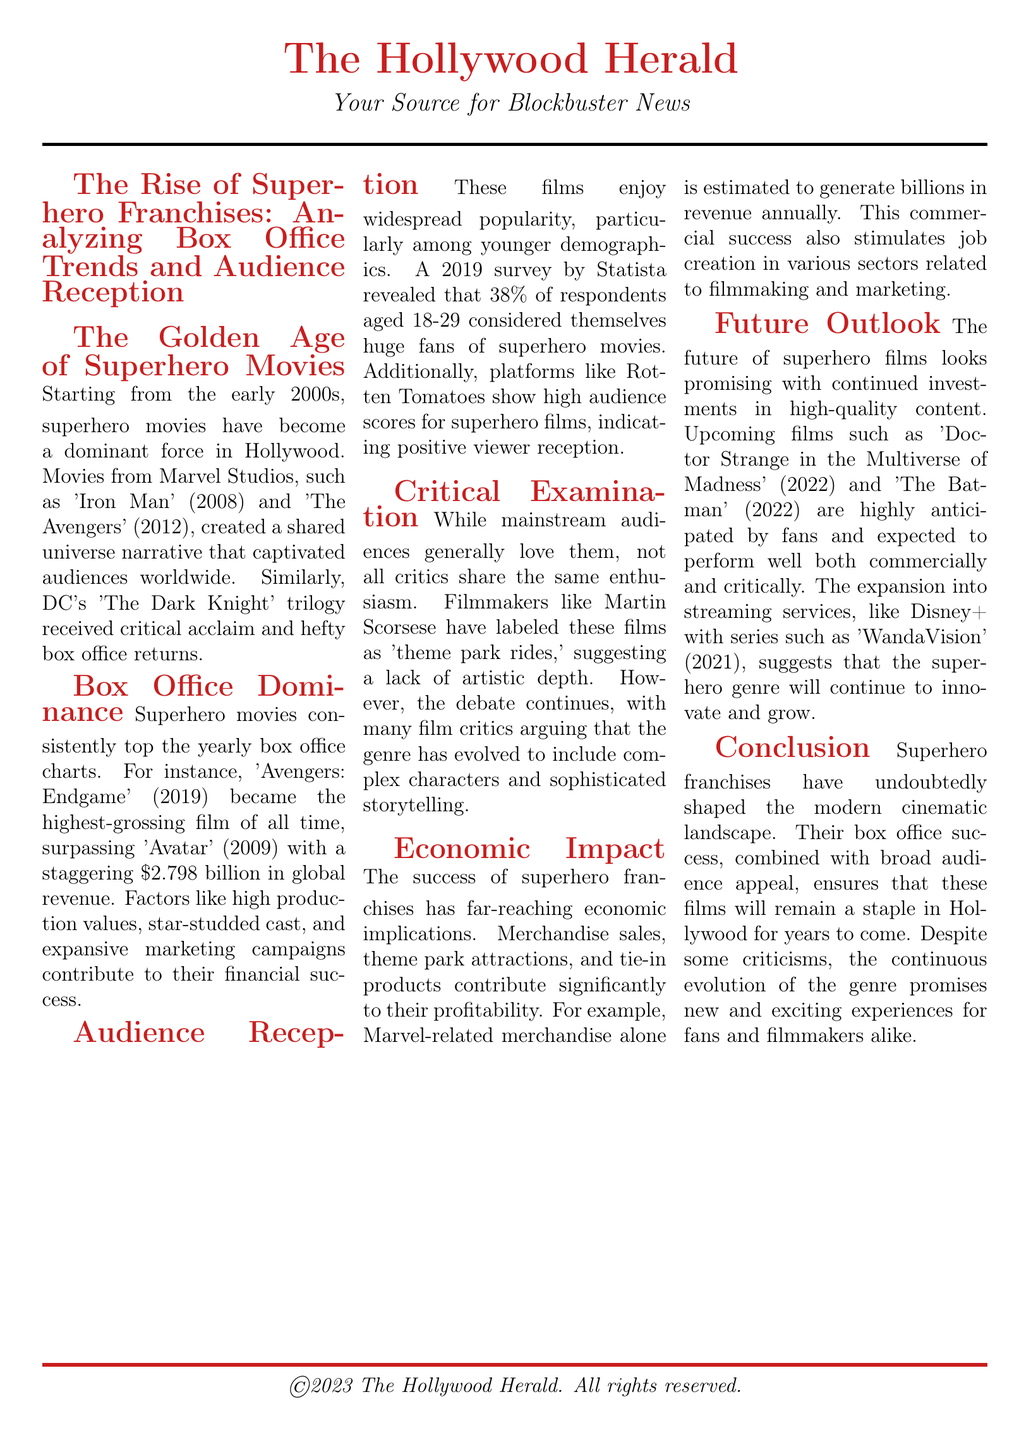What film became the highest-grossing of all time? The document states that 'Avengers: Endgame' became the highest-grossing film of all time.
Answer: 'Avengers: Endgame' What year did 'Iron Man' release? The document mentions that 'Iron Man' was released in 2008.
Answer: 2008 What percentage of respondents aged 18-29 considered themselves huge fans of superhero movies? A survey revealed that 38% of respondents aged 18-29 considered themselves huge fans.
Answer: 38% Who criticized superhero films as 'theme park rides'? The document specifies that filmmaker Martin Scorsese criticized superhero films in this way.
Answer: Martin Scorsese What is one factor that contributes to the financial success of superhero movies? The document lists high production values as a contributing factor to the financial success of superhero movies.
Answer: High production values How many billion in revenue does Marvel-related merchandise generate annually? The document indicates that Marvel-related merchandise is estimated to generate billions in revenue annually.
Answer: Billions What upcoming film is mentioned in the future outlook? The document lists 'Doctor Strange in the Multiverse of Madness' as an upcoming film.
Answer: 'Doctor Strange in the Multiverse of Madness' What impact do superhero franchises have on job creation? The document states that the commercial success of superhero films stimulates job creation in various sectors.
Answer: Job creation What is the main theme of the conclusion section? The conclusion emphasizes that superhero franchises have shaped the modern cinematic landscape.
Answer: Shaped the modern cinematic landscape 